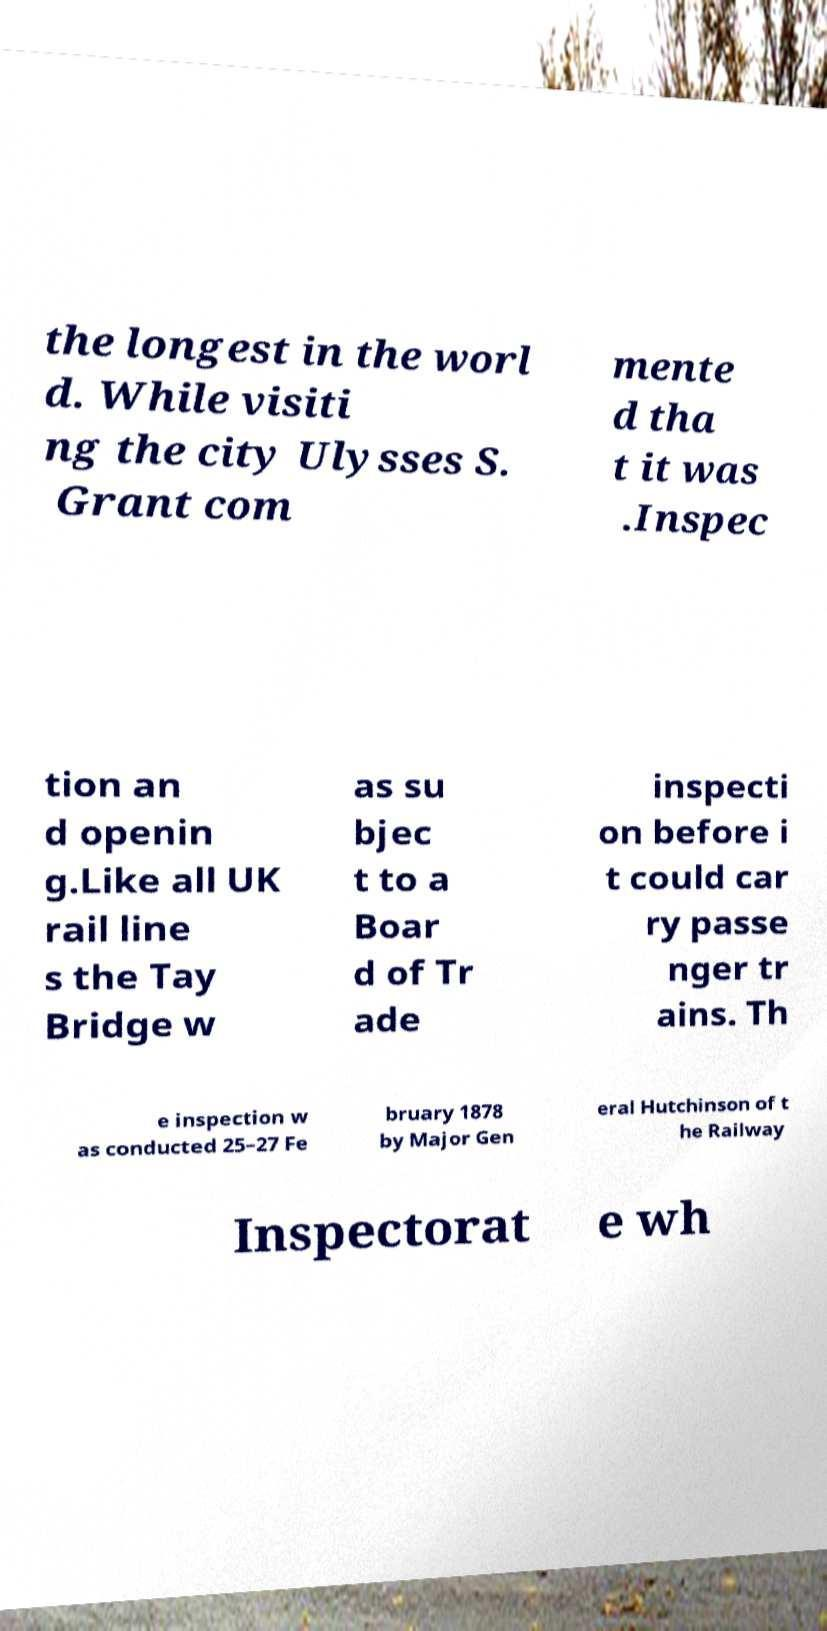For documentation purposes, I need the text within this image transcribed. Could you provide that? the longest in the worl d. While visiti ng the city Ulysses S. Grant com mente d tha t it was .Inspec tion an d openin g.Like all UK rail line s the Tay Bridge w as su bjec t to a Boar d of Tr ade inspecti on before i t could car ry passe nger tr ains. Th e inspection w as conducted 25–27 Fe bruary 1878 by Major Gen eral Hutchinson of t he Railway Inspectorat e wh 